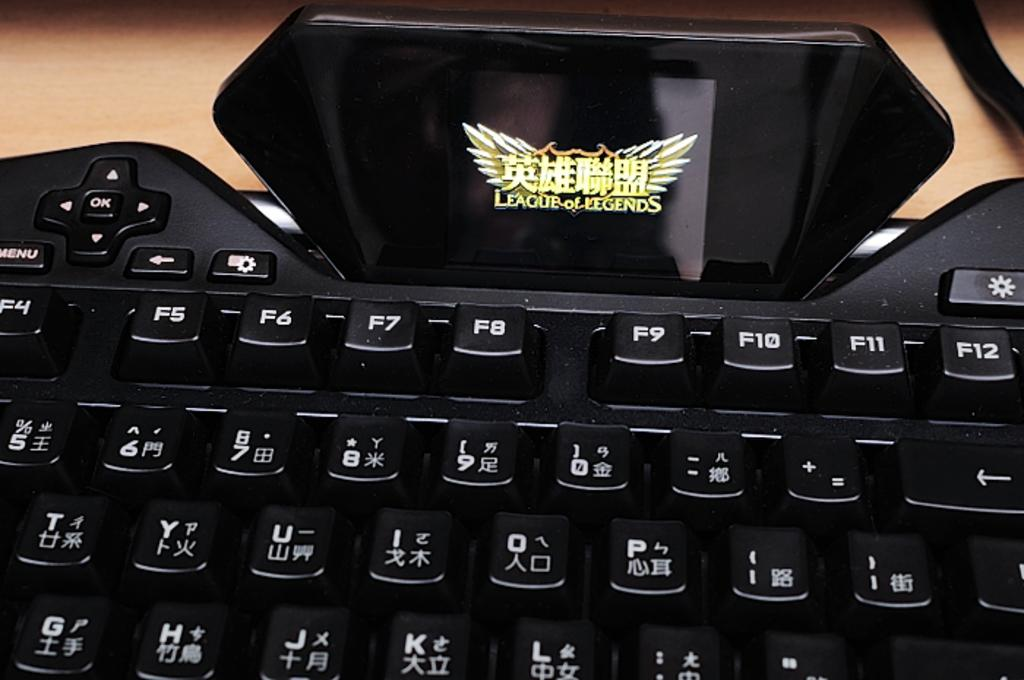<image>
Write a terse but informative summary of the picture. A close up of a keyboard with Roman and Chinese characters and a "League of Legends" placard on top. 